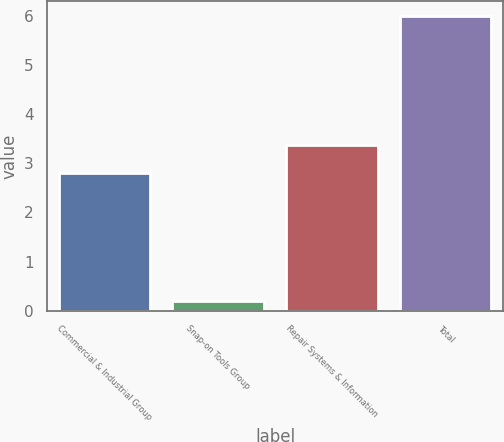<chart> <loc_0><loc_0><loc_500><loc_500><bar_chart><fcel>Commercial & Industrial Group<fcel>Snap-on Tools Group<fcel>Repair Systems & Information<fcel>Total<nl><fcel>2.8<fcel>0.2<fcel>3.38<fcel>6<nl></chart> 